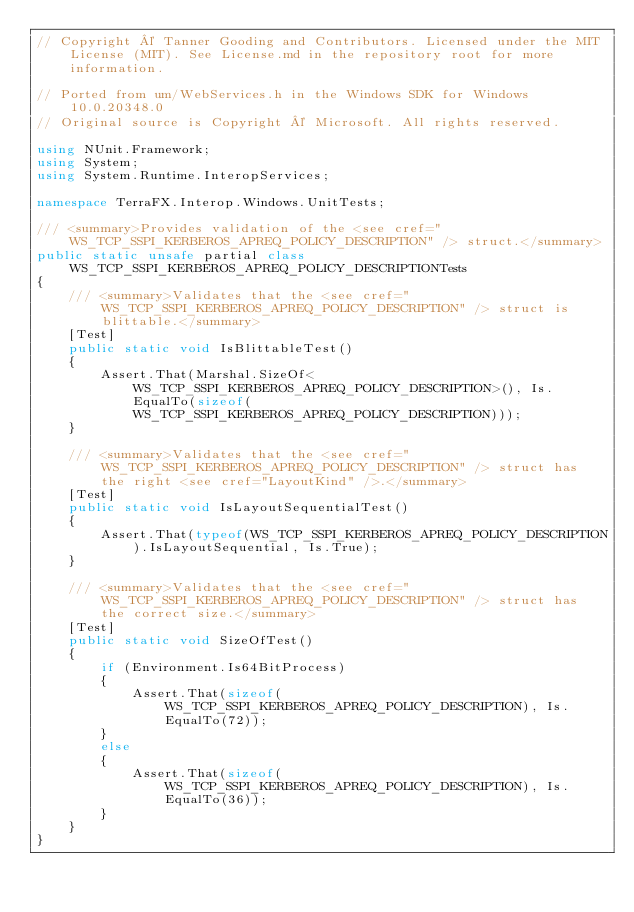<code> <loc_0><loc_0><loc_500><loc_500><_C#_>// Copyright © Tanner Gooding and Contributors. Licensed under the MIT License (MIT). See License.md in the repository root for more information.

// Ported from um/WebServices.h in the Windows SDK for Windows 10.0.20348.0
// Original source is Copyright © Microsoft. All rights reserved.

using NUnit.Framework;
using System;
using System.Runtime.InteropServices;

namespace TerraFX.Interop.Windows.UnitTests;

/// <summary>Provides validation of the <see cref="WS_TCP_SSPI_KERBEROS_APREQ_POLICY_DESCRIPTION" /> struct.</summary>
public static unsafe partial class WS_TCP_SSPI_KERBEROS_APREQ_POLICY_DESCRIPTIONTests
{
    /// <summary>Validates that the <see cref="WS_TCP_SSPI_KERBEROS_APREQ_POLICY_DESCRIPTION" /> struct is blittable.</summary>
    [Test]
    public static void IsBlittableTest()
    {
        Assert.That(Marshal.SizeOf<WS_TCP_SSPI_KERBEROS_APREQ_POLICY_DESCRIPTION>(), Is.EqualTo(sizeof(WS_TCP_SSPI_KERBEROS_APREQ_POLICY_DESCRIPTION)));
    }

    /// <summary>Validates that the <see cref="WS_TCP_SSPI_KERBEROS_APREQ_POLICY_DESCRIPTION" /> struct has the right <see cref="LayoutKind" />.</summary>
    [Test]
    public static void IsLayoutSequentialTest()
    {
        Assert.That(typeof(WS_TCP_SSPI_KERBEROS_APREQ_POLICY_DESCRIPTION).IsLayoutSequential, Is.True);
    }

    /// <summary>Validates that the <see cref="WS_TCP_SSPI_KERBEROS_APREQ_POLICY_DESCRIPTION" /> struct has the correct size.</summary>
    [Test]
    public static void SizeOfTest()
    {
        if (Environment.Is64BitProcess)
        {
            Assert.That(sizeof(WS_TCP_SSPI_KERBEROS_APREQ_POLICY_DESCRIPTION), Is.EqualTo(72));
        }
        else
        {
            Assert.That(sizeof(WS_TCP_SSPI_KERBEROS_APREQ_POLICY_DESCRIPTION), Is.EqualTo(36));
        }
    }
}
</code> 